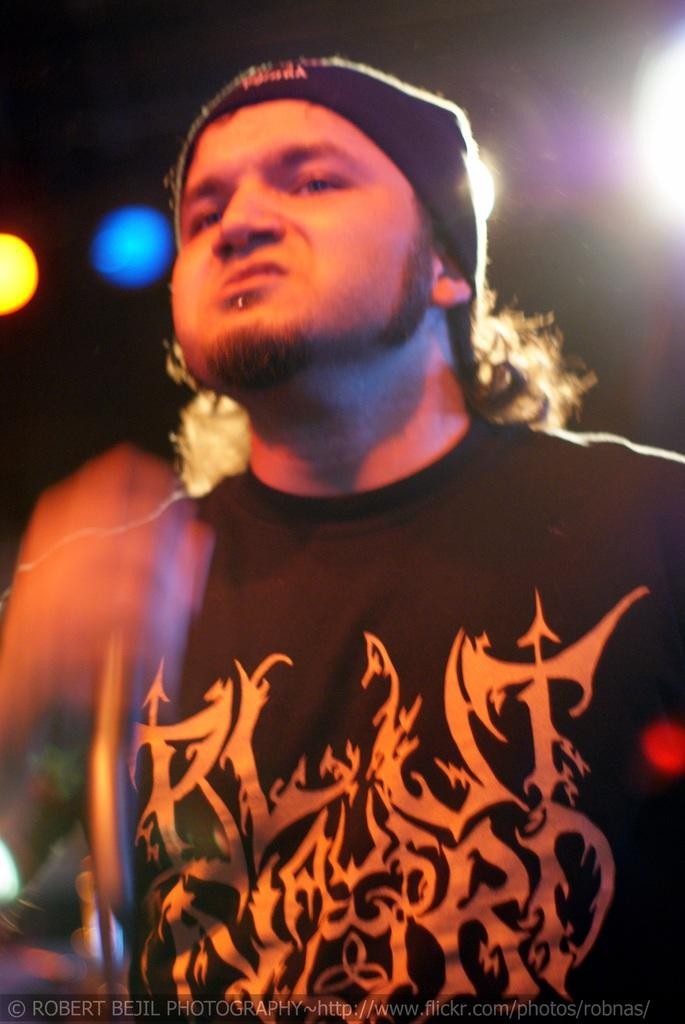Who is the main subject in the image? There is a man in the image. What is the man wearing on his head? The man is wearing a band around his head. What can be observed about the background of the image? The background of the image is dark. What type of slope can be seen in the background of the image? There is no slope present in the image; the background is dark. 